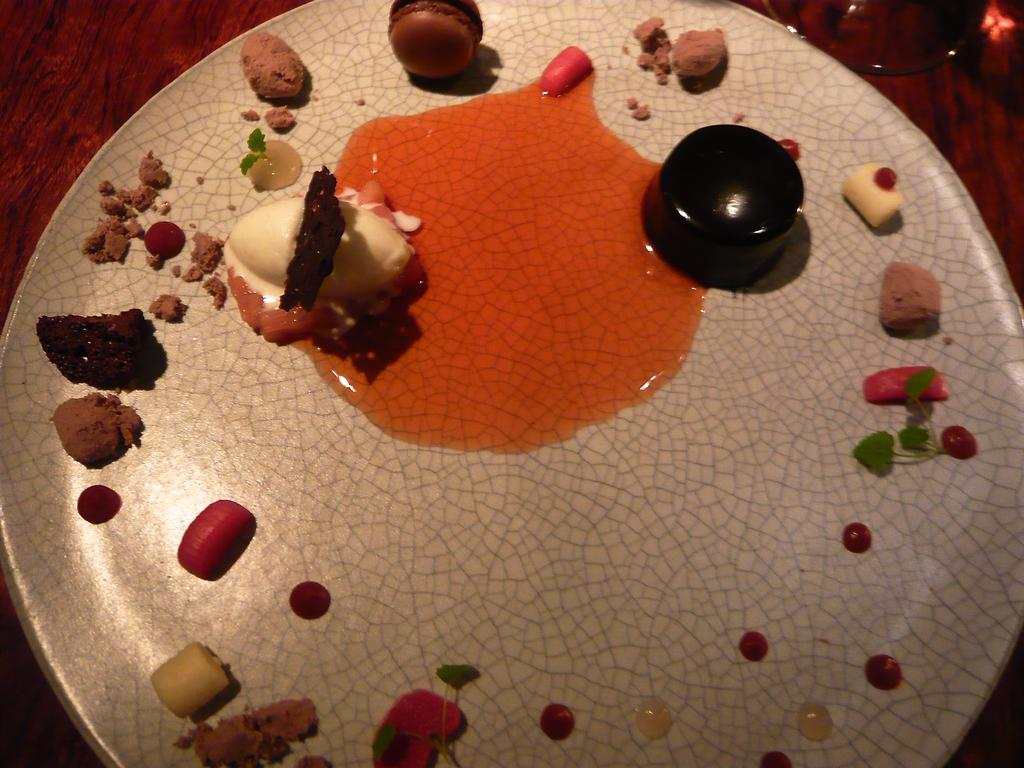What is present on the plate in the image? The plate has objects on it. Can you describe the glass in the image? The glass is truncated or partially visible. How many trees are visible in the image? There are no trees present in the image. What type of hat is the judge wearing in the image? There is no judge or hat present in the image. 